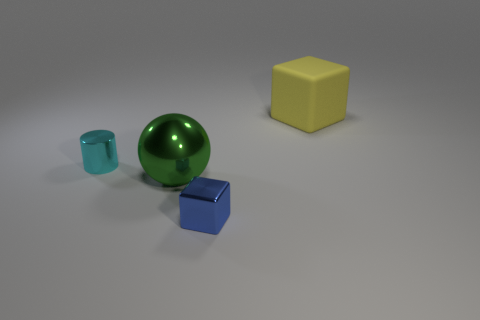How many blue things are either metallic cylinders or small cubes?
Your answer should be compact. 1. What number of other things are the same size as the blue object?
Provide a succinct answer. 1. How many tiny cubes are there?
Offer a very short reply. 1. Is there any other thing that has the same shape as the yellow object?
Provide a succinct answer. Yes. Are the object to the right of the tiny metal block and the object in front of the big green object made of the same material?
Your response must be concise. No. What is the tiny blue block made of?
Offer a very short reply. Metal. How many big spheres are made of the same material as the big green object?
Your response must be concise. 0. What number of shiny objects are either large blocks or tiny cyan objects?
Offer a terse response. 1. Does the big thing that is in front of the matte cube have the same shape as the small object that is to the left of the blue shiny block?
Ensure brevity in your answer.  No. There is a thing that is to the right of the big green thing and on the left side of the yellow object; what is its color?
Give a very brief answer. Blue. 